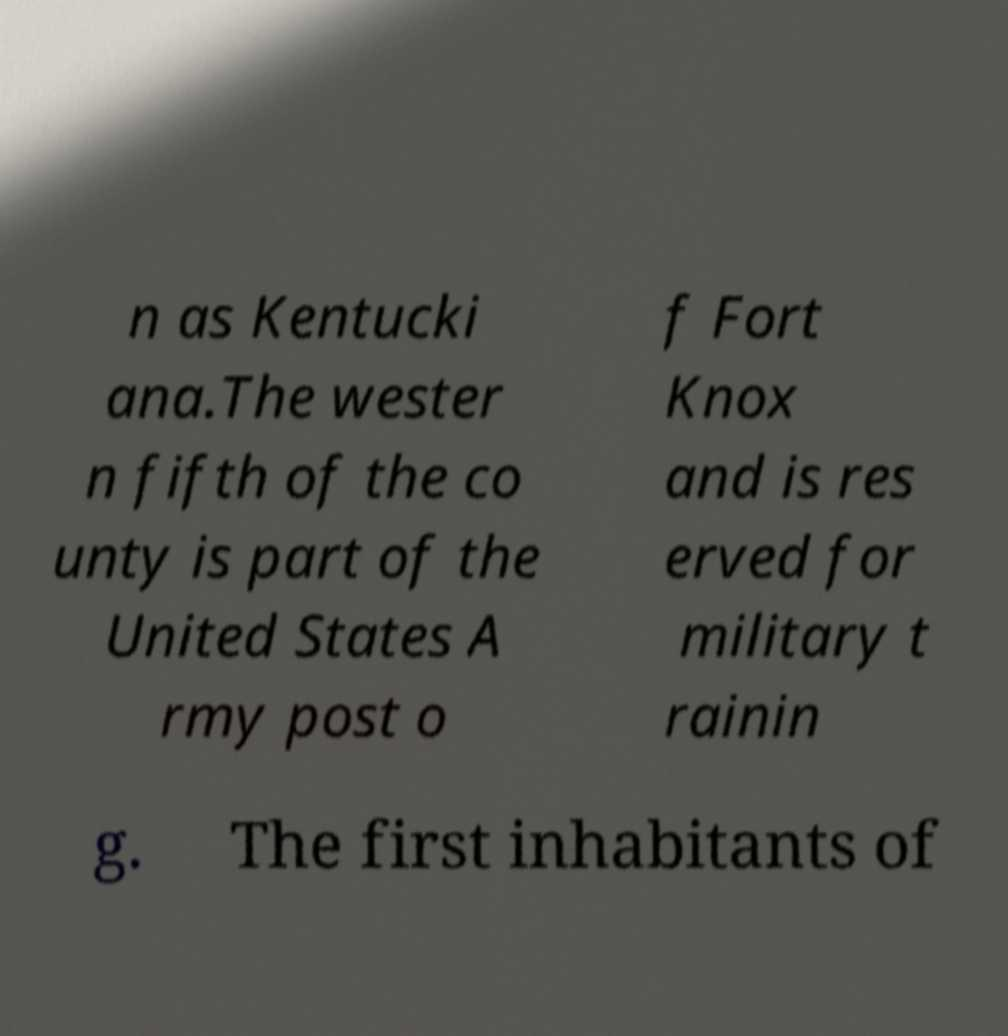Could you extract and type out the text from this image? n as Kentucki ana.The wester n fifth of the co unty is part of the United States A rmy post o f Fort Knox and is res erved for military t rainin g. The first inhabitants of 